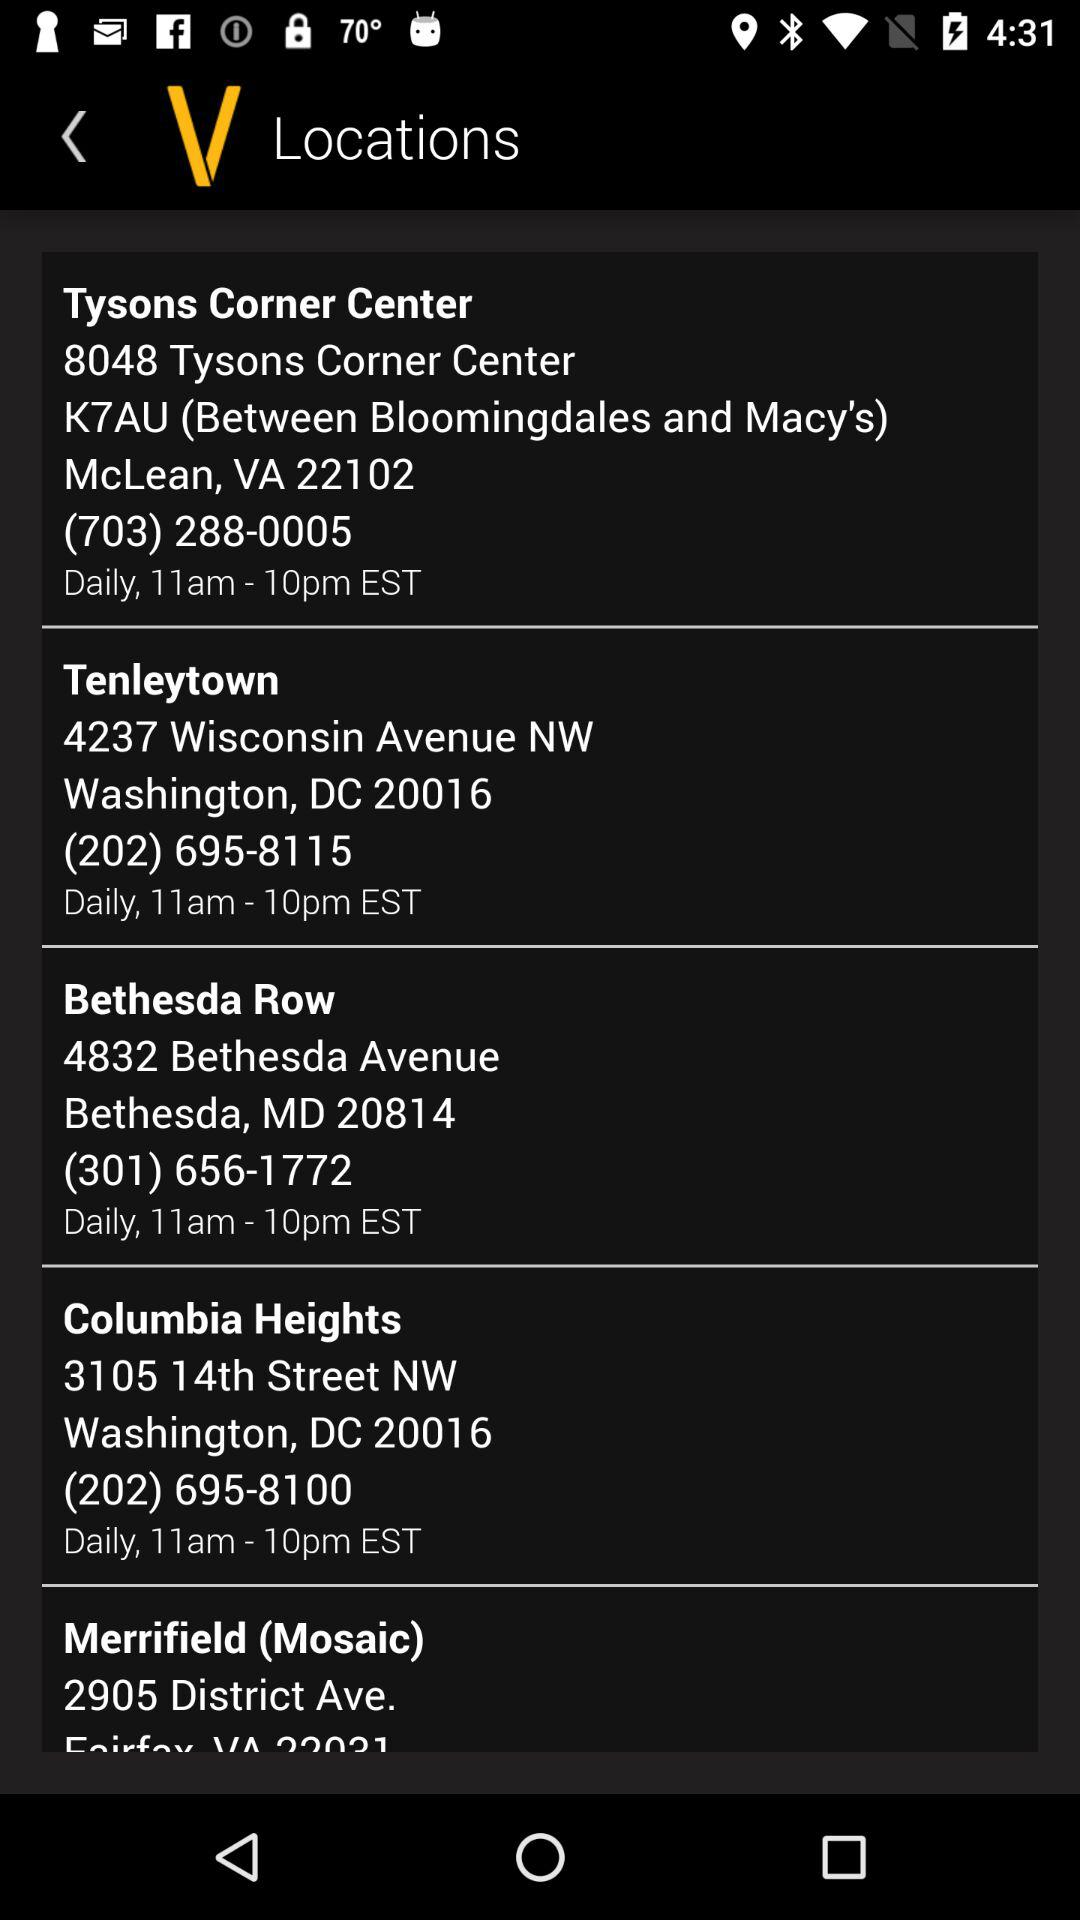What is the location of "Tysons Corner Center"? The location is 8048 Tysons Corner Center, K7AU (between Bloomingdales and Macy's), McLean, VA 22102. 